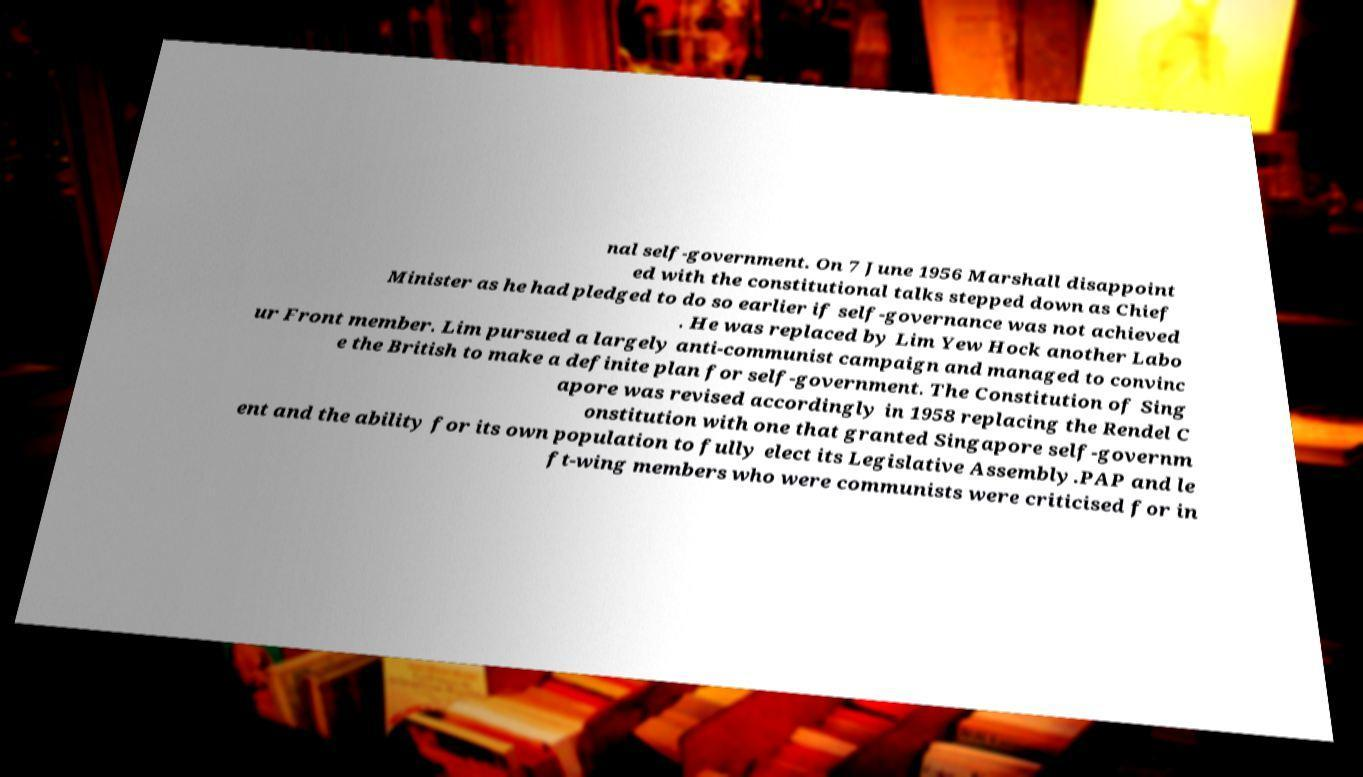Could you extract and type out the text from this image? nal self-government. On 7 June 1956 Marshall disappoint ed with the constitutional talks stepped down as Chief Minister as he had pledged to do so earlier if self-governance was not achieved . He was replaced by Lim Yew Hock another Labo ur Front member. Lim pursued a largely anti-communist campaign and managed to convinc e the British to make a definite plan for self-government. The Constitution of Sing apore was revised accordingly in 1958 replacing the Rendel C onstitution with one that granted Singapore self-governm ent and the ability for its own population to fully elect its Legislative Assembly.PAP and le ft-wing members who were communists were criticised for in 